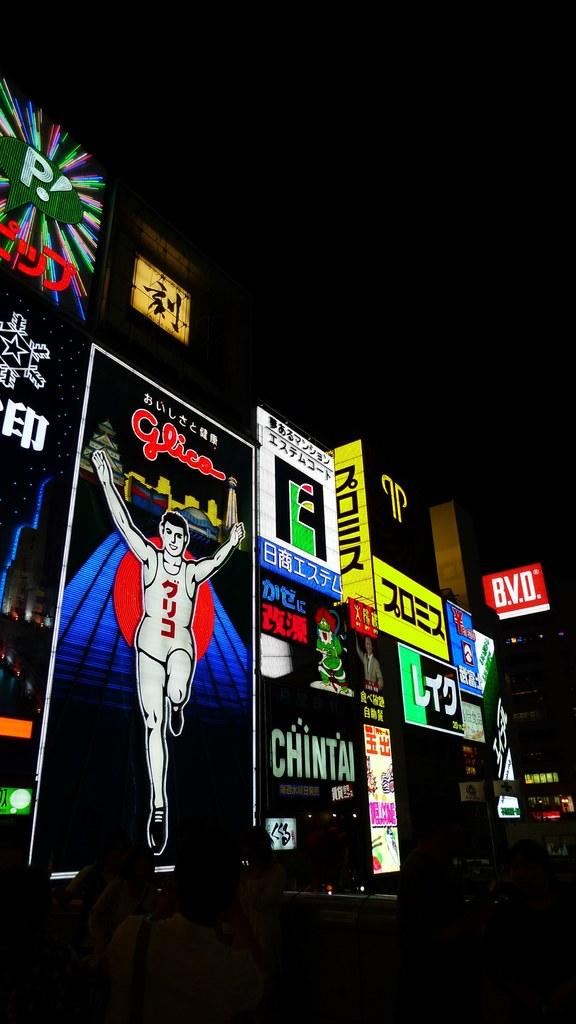<image>
Summarize the visual content of the image. An ad for CHINTAI lights up the dark night sky 